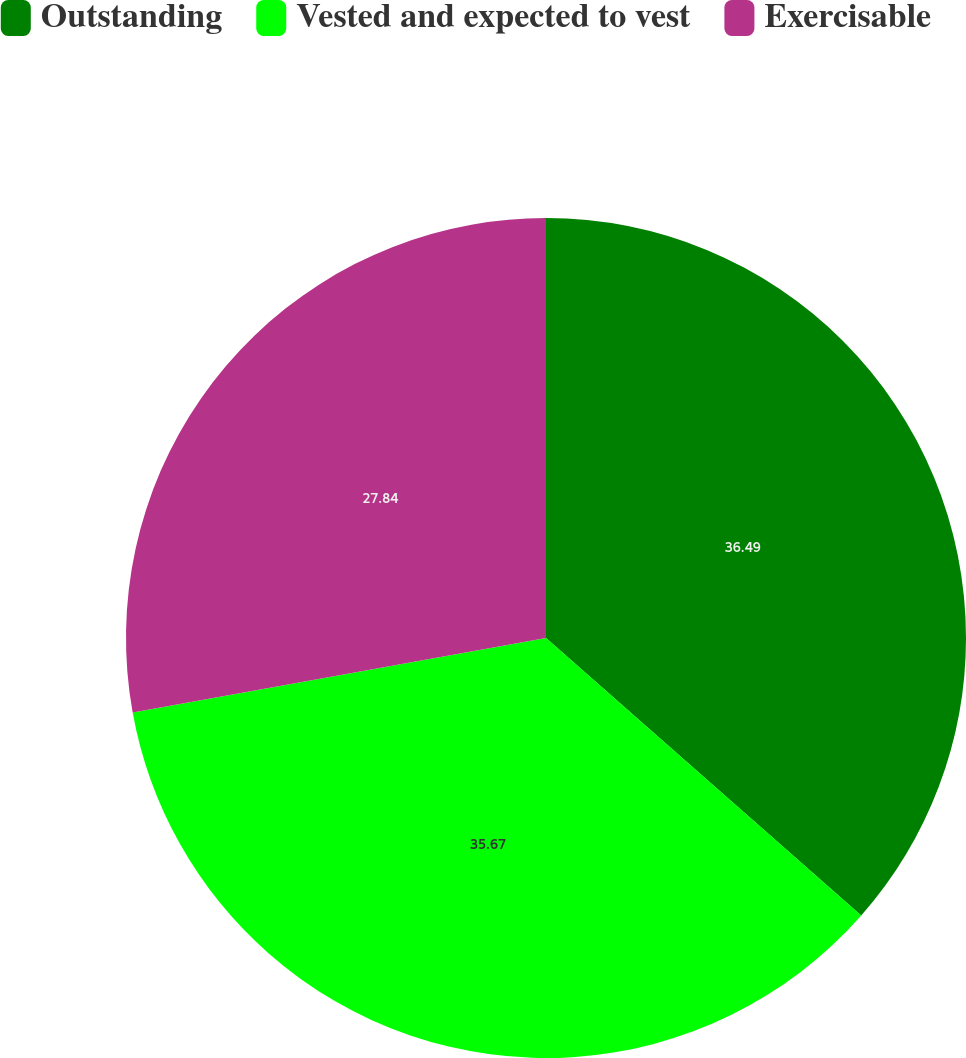Convert chart to OTSL. <chart><loc_0><loc_0><loc_500><loc_500><pie_chart><fcel>Outstanding<fcel>Vested and expected to vest<fcel>Exercisable<nl><fcel>36.49%<fcel>35.67%<fcel>27.84%<nl></chart> 